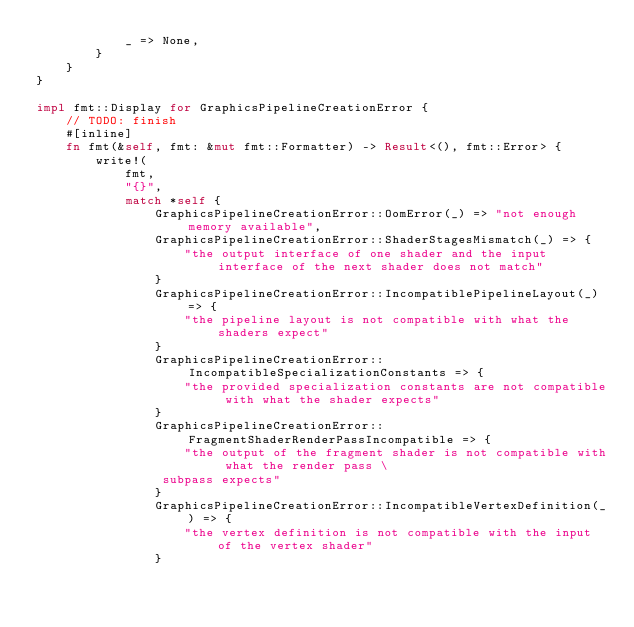Convert code to text. <code><loc_0><loc_0><loc_500><loc_500><_Rust_>            _ => None,
        }
    }
}

impl fmt::Display for GraphicsPipelineCreationError {
    // TODO: finish
    #[inline]
    fn fmt(&self, fmt: &mut fmt::Formatter) -> Result<(), fmt::Error> {
        write!(
            fmt,
            "{}",
            match *self {
                GraphicsPipelineCreationError::OomError(_) => "not enough memory available",
                GraphicsPipelineCreationError::ShaderStagesMismatch(_) => {
                    "the output interface of one shader and the input interface of the next shader does not match"
                }
                GraphicsPipelineCreationError::IncompatiblePipelineLayout(_) => {
                    "the pipeline layout is not compatible with what the shaders expect"
                }
                GraphicsPipelineCreationError::IncompatibleSpecializationConstants => {
                    "the provided specialization constants are not compatible with what the shader expects"
                }
                GraphicsPipelineCreationError::FragmentShaderRenderPassIncompatible => {
                    "the output of the fragment shader is not compatible with what the render pass \
                 subpass expects"
                }
                GraphicsPipelineCreationError::IncompatibleVertexDefinition(_) => {
                    "the vertex definition is not compatible with the input of the vertex shader"
                }</code> 